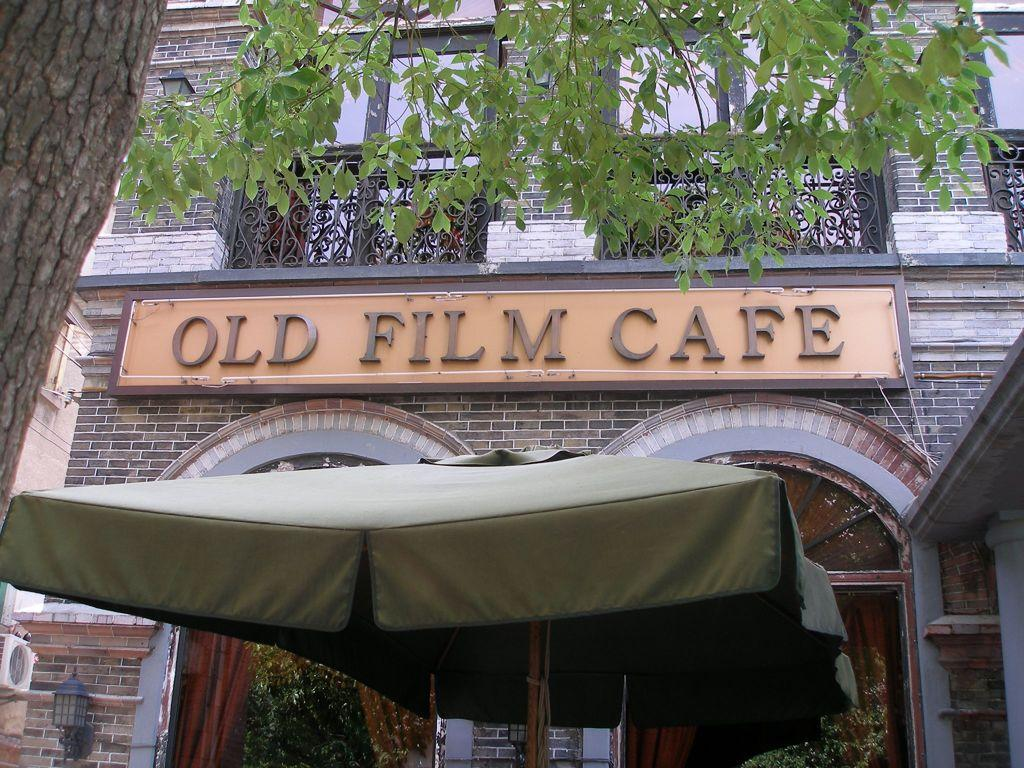What structure can be seen in the image? There is a tent in the image. What is the color of the tent? The tent is brown in color. What can be seen in the background of the image? There is a board attached to a building, windows, and a tree in the background. What is the color of the tree in the background? The tree in the background is green in color. How does the belief system of the rat affect its interaction with the tent in the image? There is no rat present in the image, and therefore no belief system or interaction with the tent can be observed. 